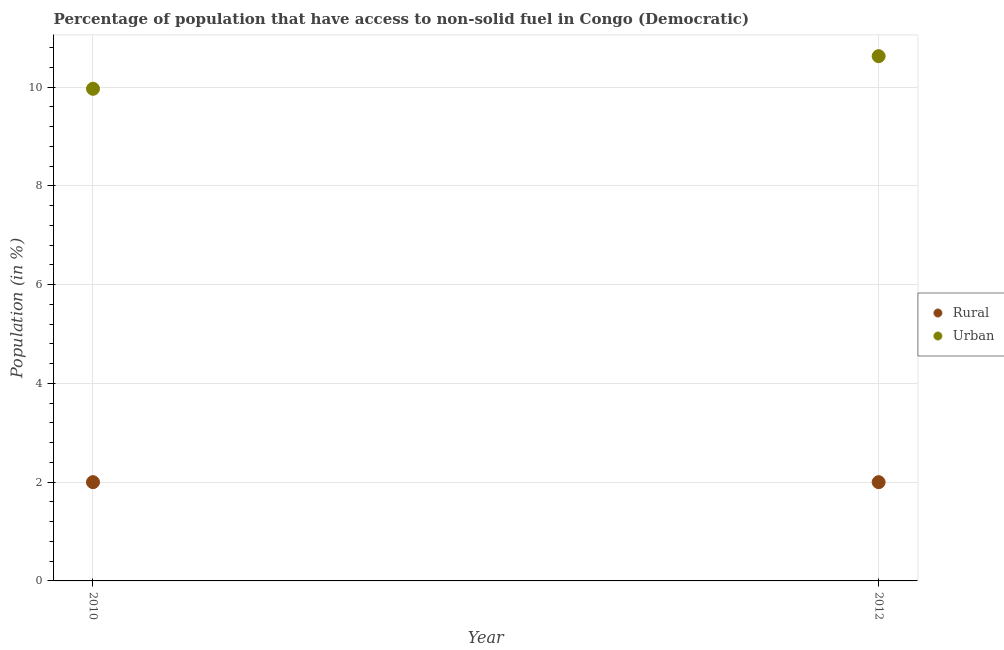How many different coloured dotlines are there?
Provide a succinct answer. 2. Is the number of dotlines equal to the number of legend labels?
Offer a very short reply. Yes. What is the urban population in 2010?
Your answer should be compact. 9.97. Across all years, what is the maximum urban population?
Make the answer very short. 10.63. Across all years, what is the minimum rural population?
Provide a short and direct response. 2. In which year was the urban population maximum?
Offer a terse response. 2012. What is the total urban population in the graph?
Your response must be concise. 20.59. What is the difference between the urban population in 2010 and that in 2012?
Give a very brief answer. -0.66. What is the difference between the urban population in 2010 and the rural population in 2012?
Provide a succinct answer. 7.97. What is the average urban population per year?
Provide a short and direct response. 10.3. In the year 2010, what is the difference between the urban population and rural population?
Your response must be concise. 7.97. Is the rural population in 2010 less than that in 2012?
Make the answer very short. No. How many dotlines are there?
Your answer should be compact. 2. How many years are there in the graph?
Provide a short and direct response. 2. Are the values on the major ticks of Y-axis written in scientific E-notation?
Give a very brief answer. No. Does the graph contain any zero values?
Provide a succinct answer. No. Where does the legend appear in the graph?
Provide a short and direct response. Center right. How are the legend labels stacked?
Make the answer very short. Vertical. What is the title of the graph?
Make the answer very short. Percentage of population that have access to non-solid fuel in Congo (Democratic). What is the label or title of the Y-axis?
Offer a terse response. Population (in %). What is the Population (in %) in Rural in 2010?
Your answer should be compact. 2. What is the Population (in %) in Urban in 2010?
Your answer should be very brief. 9.97. What is the Population (in %) of Rural in 2012?
Your answer should be very brief. 2. What is the Population (in %) in Urban in 2012?
Provide a short and direct response. 10.63. Across all years, what is the maximum Population (in %) of Rural?
Give a very brief answer. 2. Across all years, what is the maximum Population (in %) of Urban?
Your answer should be very brief. 10.63. Across all years, what is the minimum Population (in %) in Rural?
Make the answer very short. 2. Across all years, what is the minimum Population (in %) of Urban?
Your answer should be compact. 9.97. What is the total Population (in %) in Rural in the graph?
Ensure brevity in your answer.  4. What is the total Population (in %) of Urban in the graph?
Offer a terse response. 20.59. What is the difference between the Population (in %) of Rural in 2010 and that in 2012?
Offer a terse response. 0. What is the difference between the Population (in %) in Urban in 2010 and that in 2012?
Make the answer very short. -0.66. What is the difference between the Population (in %) of Rural in 2010 and the Population (in %) of Urban in 2012?
Keep it short and to the point. -8.63. What is the average Population (in %) in Urban per year?
Provide a short and direct response. 10.3. In the year 2010, what is the difference between the Population (in %) of Rural and Population (in %) of Urban?
Provide a short and direct response. -7.97. In the year 2012, what is the difference between the Population (in %) of Rural and Population (in %) of Urban?
Keep it short and to the point. -8.63. What is the ratio of the Population (in %) of Urban in 2010 to that in 2012?
Your response must be concise. 0.94. What is the difference between the highest and the second highest Population (in %) of Rural?
Ensure brevity in your answer.  0. What is the difference between the highest and the second highest Population (in %) in Urban?
Provide a succinct answer. 0.66. What is the difference between the highest and the lowest Population (in %) of Urban?
Give a very brief answer. 0.66. 